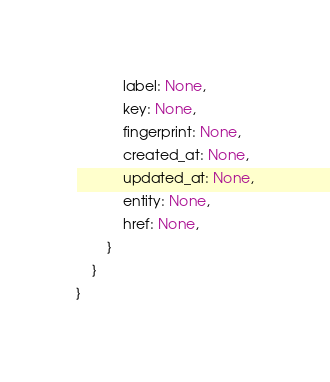<code> <loc_0><loc_0><loc_500><loc_500><_Rust_>            label: None,
            key: None,
            fingerprint: None,
            created_at: None,
            updated_at: None,
            entity: None,
            href: None,
        }
    }
}


</code> 